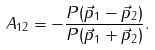Convert formula to latex. <formula><loc_0><loc_0><loc_500><loc_500>A _ { 1 2 } = - \frac { P ( \vec { p } _ { 1 } - \vec { p } _ { 2 } ) } { P ( \vec { p } _ { 1 } + \vec { p } _ { 2 } ) } .</formula> 